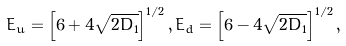<formula> <loc_0><loc_0><loc_500><loc_500>E _ { u } = \left [ 6 + 4 \sqrt { 2 D _ { 1 } } \right ] ^ { 1 / 2 } , E _ { d } = \left [ 6 - 4 \sqrt { 2 D _ { 1 } } \right ] ^ { 1 / 2 } ,</formula> 